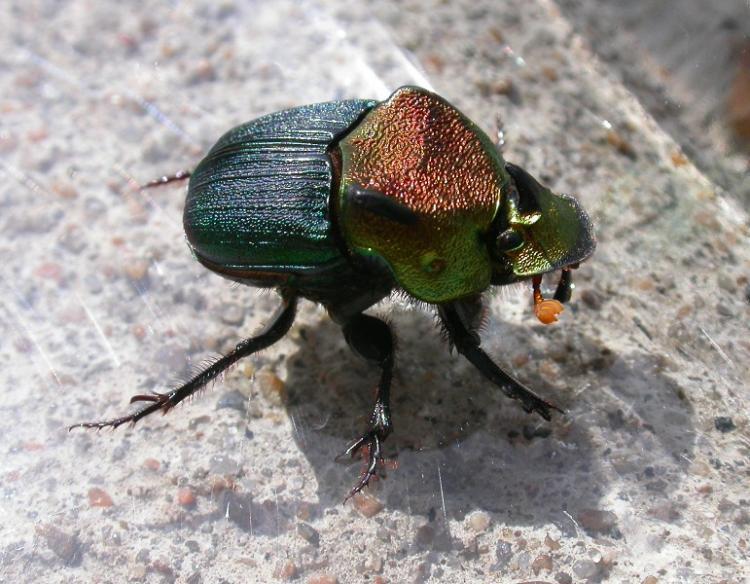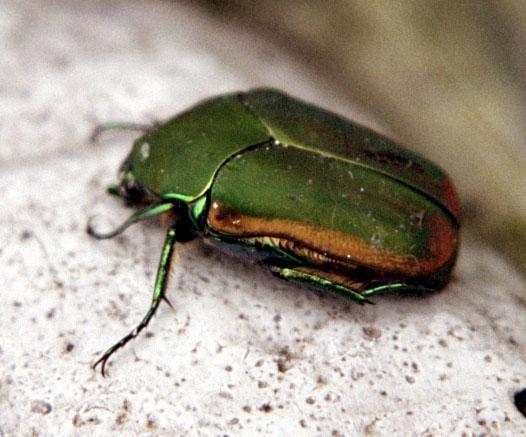The first image is the image on the left, the second image is the image on the right. Considering the images on both sides, is "All of the bugs are greenish in color." valid? Answer yes or no. Yes. 